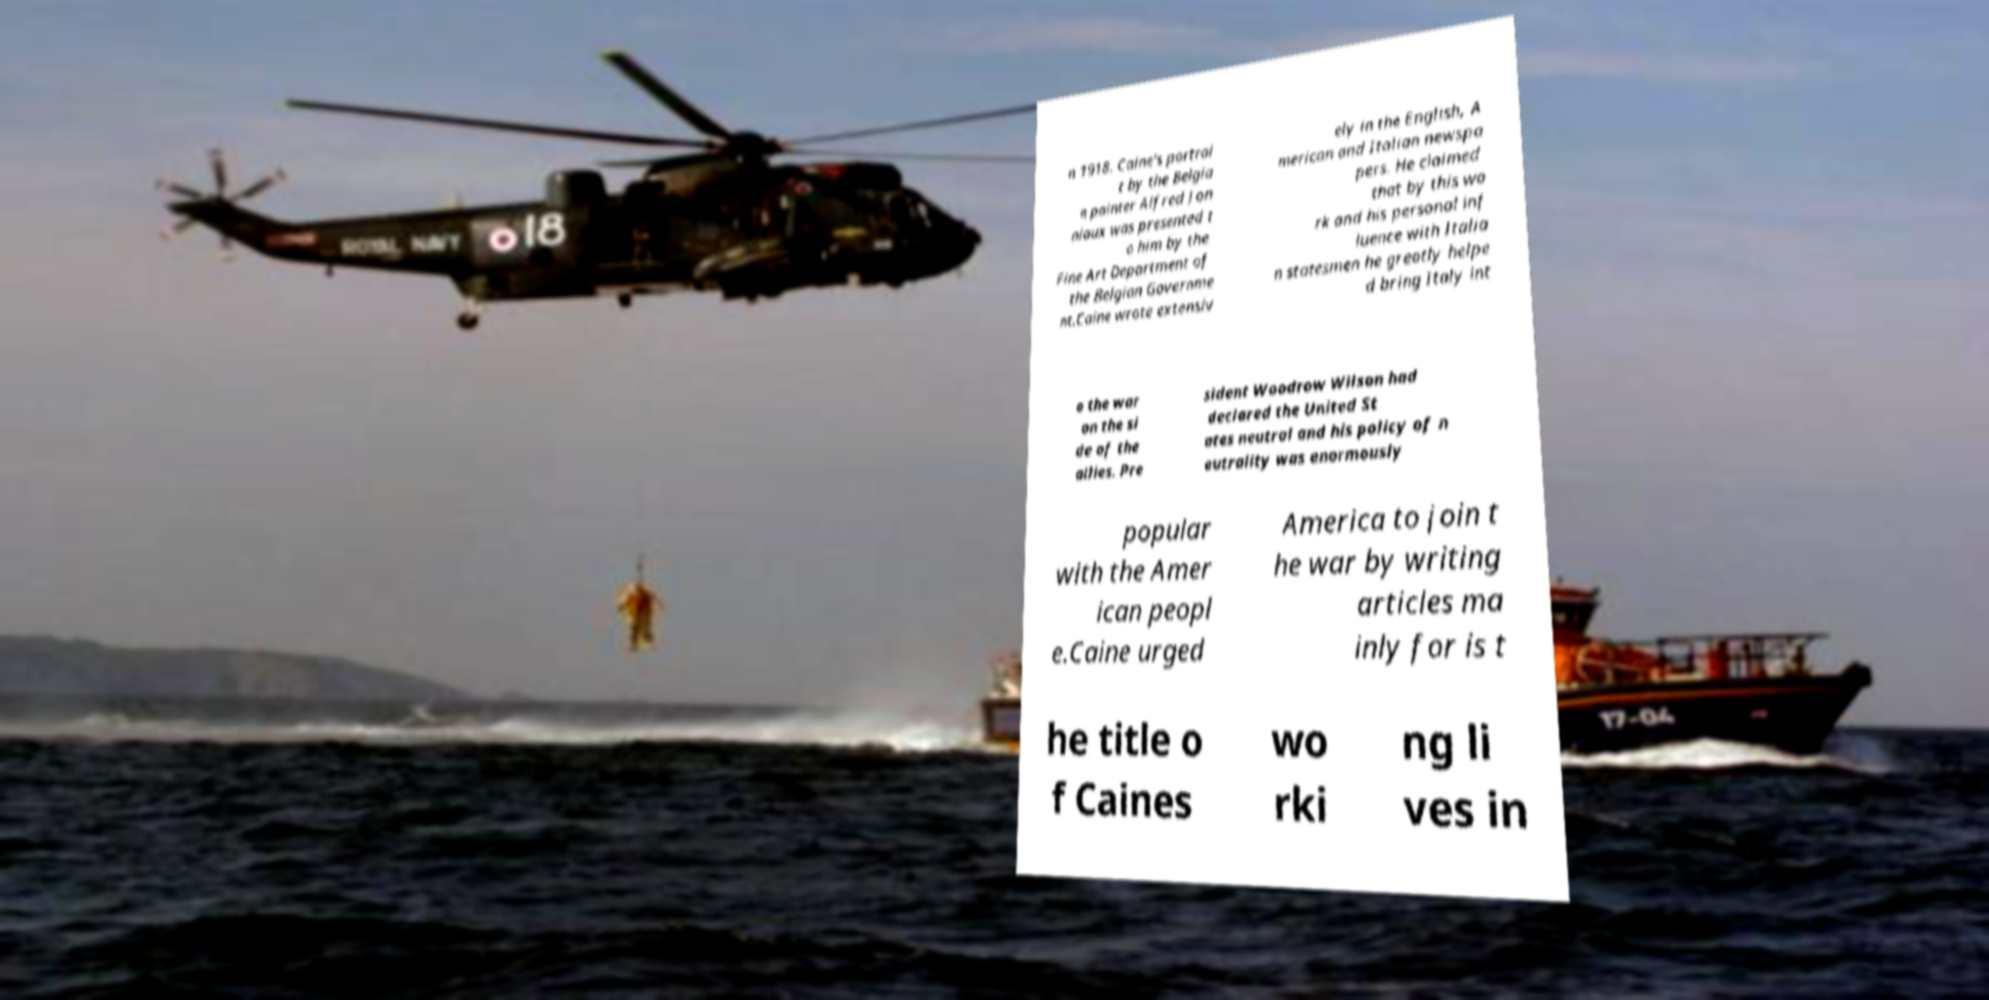What messages or text are displayed in this image? I need them in a readable, typed format. n 1918. Caine's portrai t by the Belgia n painter Alfred Jon niaux was presented t o him by the Fine Art Department of the Belgian Governme nt.Caine wrote extensiv ely in the English, A merican and Italian newspa pers. He claimed that by this wo rk and his personal inf luence with Italia n statesmen he greatly helpe d bring Italy int o the war on the si de of the allies. Pre sident Woodrow Wilson had declared the United St ates neutral and his policy of n eutrality was enormously popular with the Amer ican peopl e.Caine urged America to join t he war by writing articles ma inly for is t he title o f Caines wo rki ng li ves in 